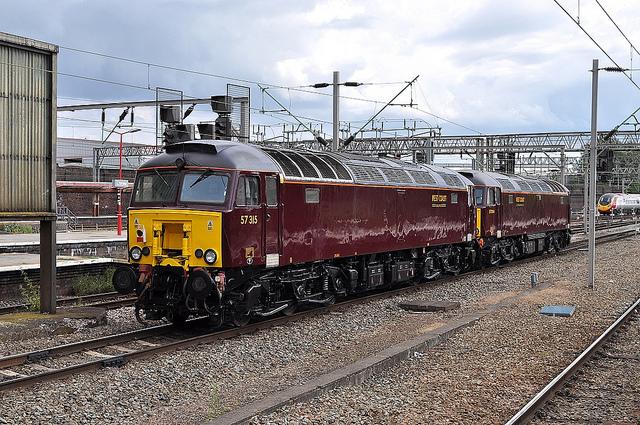Is there more than one train in the picture?
Concise answer only. Yes. How windows are on the very front of the train?
Concise answer only. 2. How many train cars can be seen?
Be succinct. 2. What color is the front of the train?
Be succinct. Yellow. Did the train just stop?
Be succinct. Yes. 